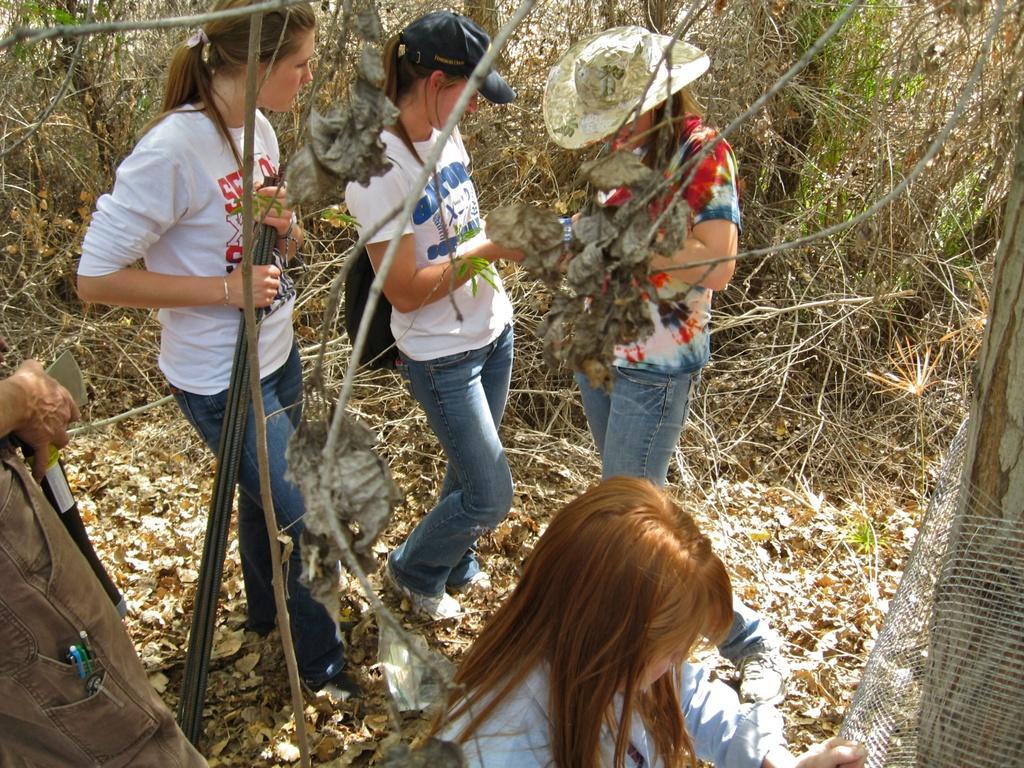Can you describe this image briefly? The image is taken in the woods. In the foreground of the picture we can see group of people, dry leaves, stems, fencing and trunk of a tree. In the background there are trees and twigs. 